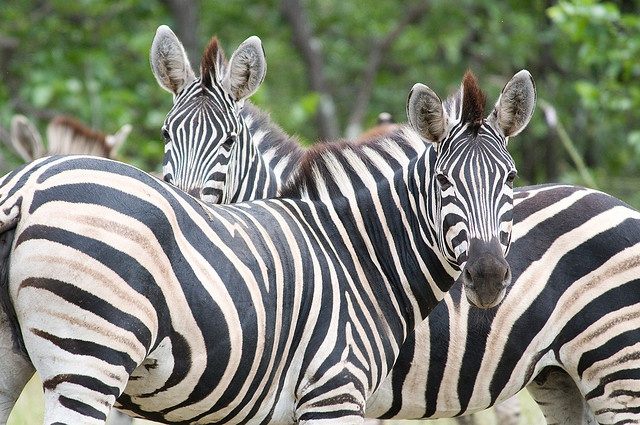Describe the objects in this image and their specific colors. I can see zebra in darkgreen, lightgray, gray, black, and darkgray tones, zebra in darkgreen, lightgray, black, gray, and darkgray tones, zebra in darkgreen, lightgray, darkgray, gray, and black tones, and zebra in darkgreen, darkgray, gray, and lightgray tones in this image. 